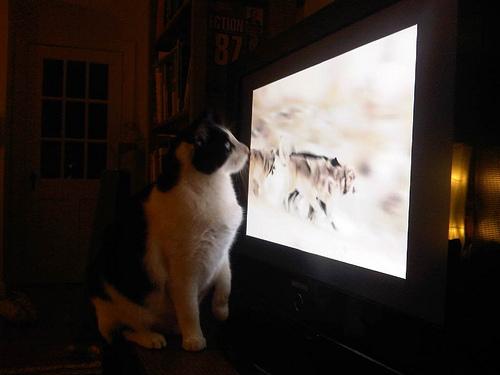What is next to the window?
Answer briefly. Cat. What is the cat sitting in front of?
Concise answer only. Tv. What is the cat lying on?
Quick response, please. Table. What direction is the cat looking?
Answer briefly. Right. Are cats good pets to have?
Concise answer only. Yes. Is the kitty looking at the camera?
Concise answer only. No. Is the television on?
Give a very brief answer. Yes. Is the cat being illuminated by natural light?
Write a very short answer. No. Is the cat interested in the TV program?
Give a very brief answer. Yes. What is the color of the cat?
Write a very short answer. Black and white. 